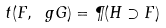Convert formula to latex. <formula><loc_0><loc_0><loc_500><loc_500>t ( F , \ g G ) = \P ( H \supset F )</formula> 